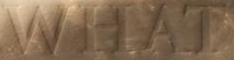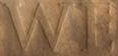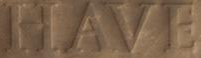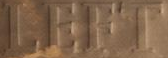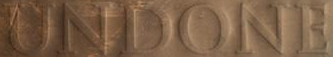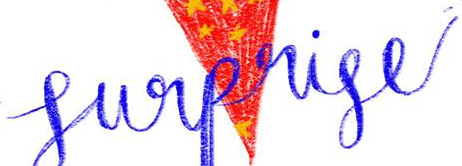Read the text from these images in sequence, separated by a semicolon. WHAT; WE; HAVE; LEFT; UNDONE; Surprise 